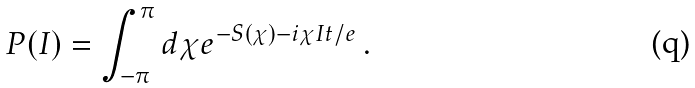<formula> <loc_0><loc_0><loc_500><loc_500>P ( I ) = \int _ { - \pi } ^ { \pi } d \chi e ^ { - S ( \chi ) - i \chi I t / e } \, .</formula> 